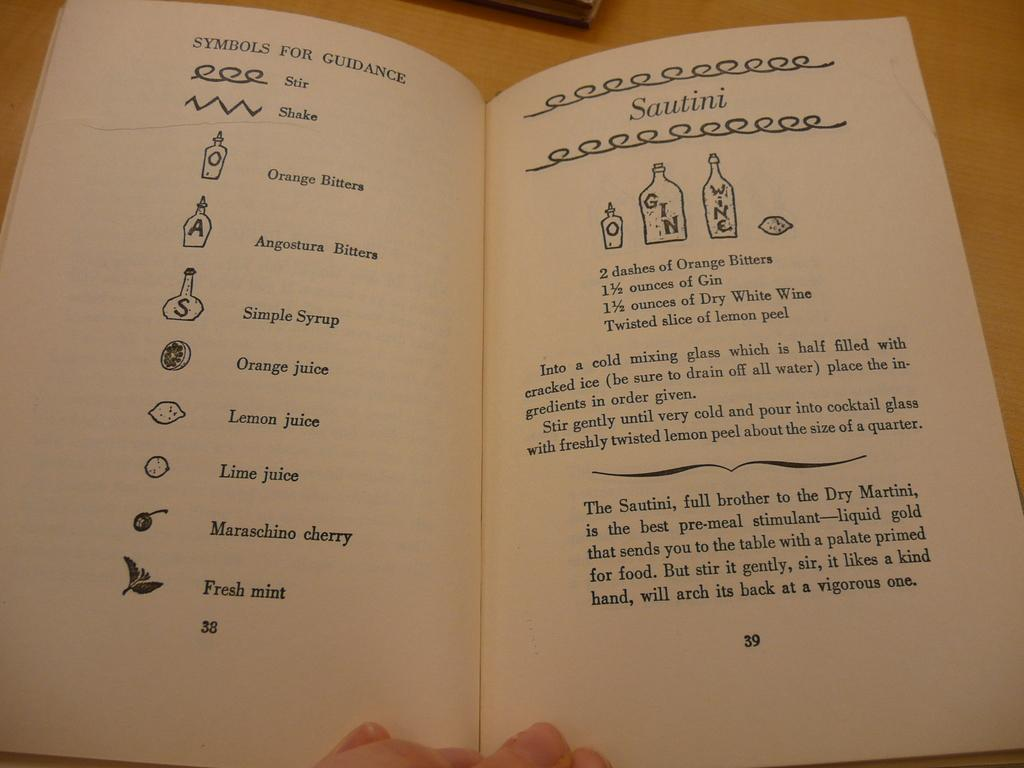Provide a one-sentence caption for the provided image. A recipe for Sautini calls for gin and dry white wine. 